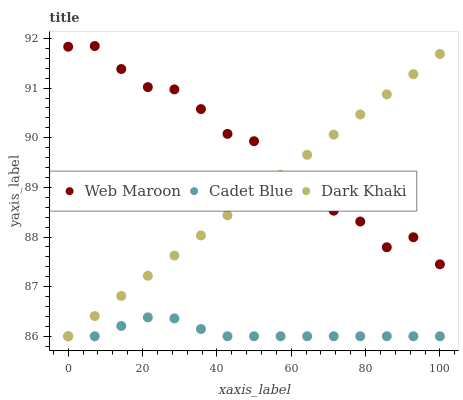Does Cadet Blue have the minimum area under the curve?
Answer yes or no. Yes. Does Web Maroon have the maximum area under the curve?
Answer yes or no. Yes. Does Web Maroon have the minimum area under the curve?
Answer yes or no. No. Does Cadet Blue have the maximum area under the curve?
Answer yes or no. No. Is Dark Khaki the smoothest?
Answer yes or no. Yes. Is Web Maroon the roughest?
Answer yes or no. Yes. Is Cadet Blue the smoothest?
Answer yes or no. No. Is Cadet Blue the roughest?
Answer yes or no. No. Does Dark Khaki have the lowest value?
Answer yes or no. Yes. Does Web Maroon have the lowest value?
Answer yes or no. No. Does Web Maroon have the highest value?
Answer yes or no. Yes. Does Cadet Blue have the highest value?
Answer yes or no. No. Is Cadet Blue less than Web Maroon?
Answer yes or no. Yes. Is Web Maroon greater than Cadet Blue?
Answer yes or no. Yes. Does Web Maroon intersect Dark Khaki?
Answer yes or no. Yes. Is Web Maroon less than Dark Khaki?
Answer yes or no. No. Is Web Maroon greater than Dark Khaki?
Answer yes or no. No. Does Cadet Blue intersect Web Maroon?
Answer yes or no. No. 